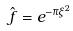<formula> <loc_0><loc_0><loc_500><loc_500>\hat { f } = e ^ { - \pi \xi ^ { 2 } }</formula> 